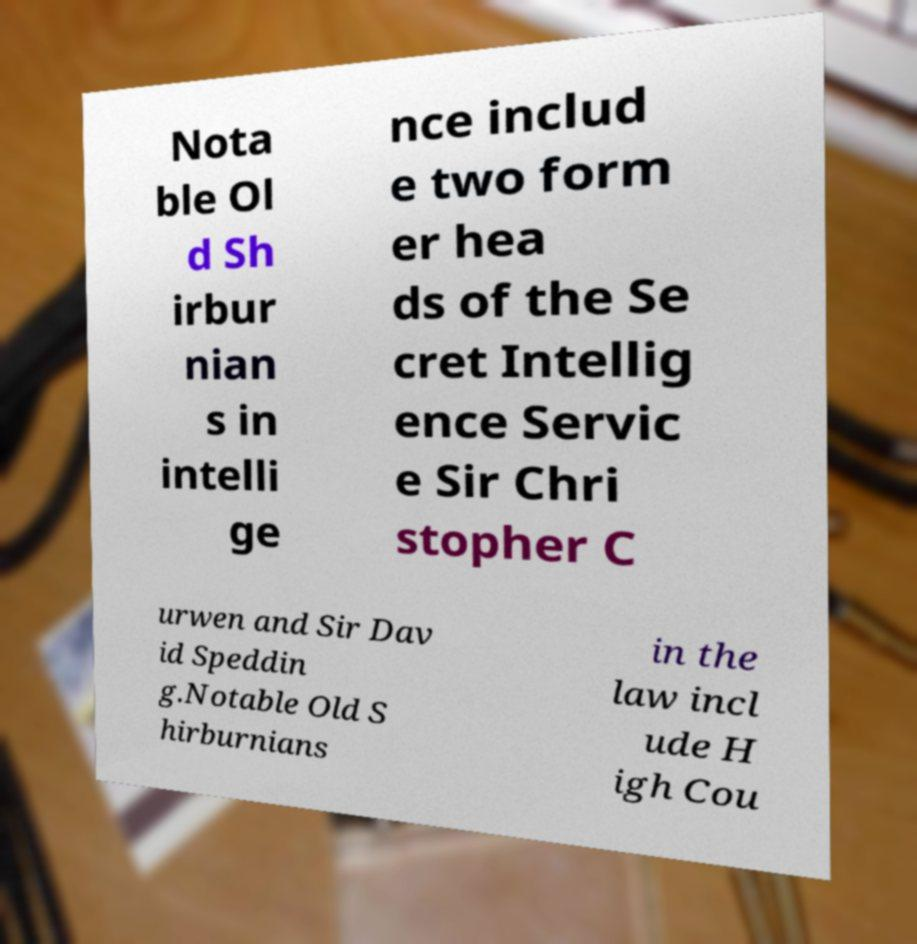Could you assist in decoding the text presented in this image and type it out clearly? Nota ble Ol d Sh irbur nian s in intelli ge nce includ e two form er hea ds of the Se cret Intellig ence Servic e Sir Chri stopher C urwen and Sir Dav id Speddin g.Notable Old S hirburnians in the law incl ude H igh Cou 